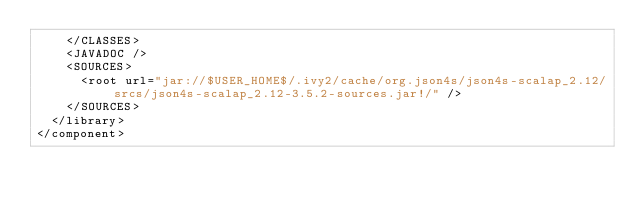Convert code to text. <code><loc_0><loc_0><loc_500><loc_500><_XML_>    </CLASSES>
    <JAVADOC />
    <SOURCES>
      <root url="jar://$USER_HOME$/.ivy2/cache/org.json4s/json4s-scalap_2.12/srcs/json4s-scalap_2.12-3.5.2-sources.jar!/" />
    </SOURCES>
  </library>
</component></code> 